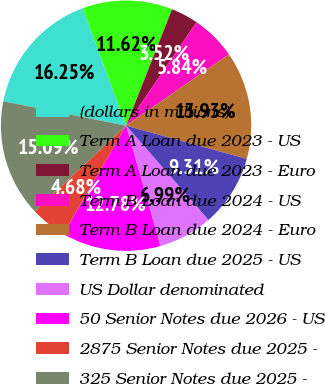Convert chart to OTSL. <chart><loc_0><loc_0><loc_500><loc_500><pie_chart><fcel>(dollars in millions)<fcel>Term A Loan due 2023 - US<fcel>Term A Loan due 2023 - Euro<fcel>Term B Loan due 2024 - US<fcel>Term B Loan due 2024 - Euro<fcel>Term B Loan due 2025 - US<fcel>US Dollar denominated<fcel>50 Senior Notes due 2026 - US<fcel>2875 Senior Notes due 2025 -<fcel>325 Senior Notes due 2025 -<nl><fcel>16.25%<fcel>11.62%<fcel>3.52%<fcel>5.84%<fcel>13.93%<fcel>9.31%<fcel>6.99%<fcel>12.78%<fcel>4.68%<fcel>15.09%<nl></chart> 